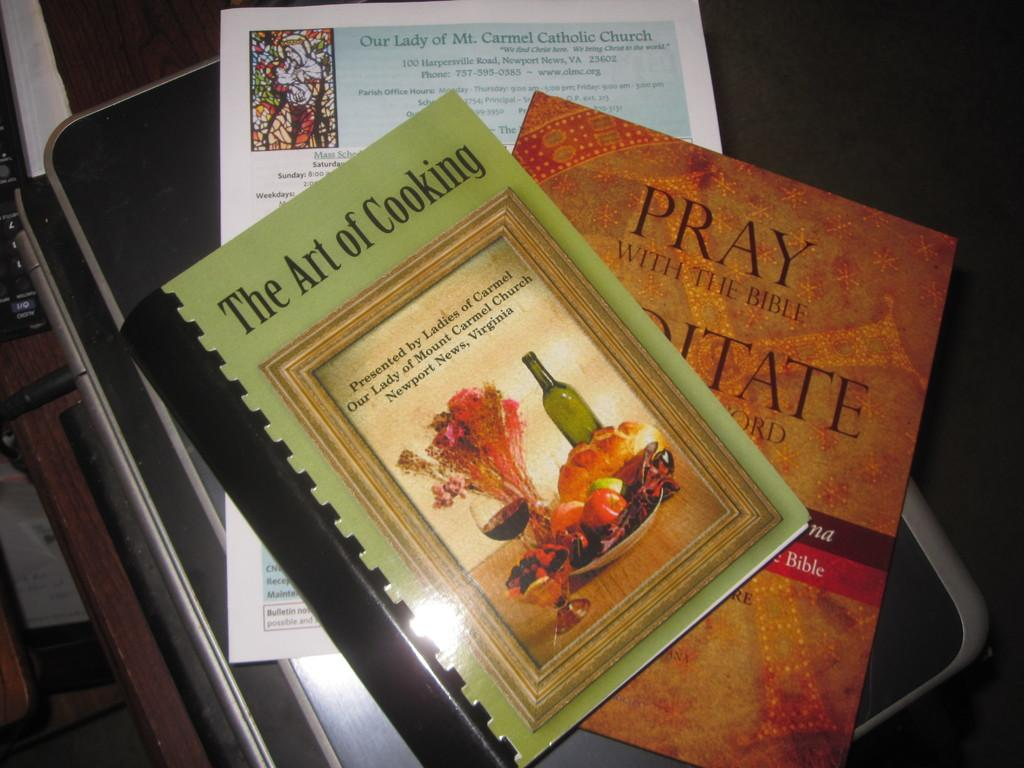<image>
Provide a brief description of the given image. A spiral bound book called the Art of Cooking sits on top of a Prayer book. 